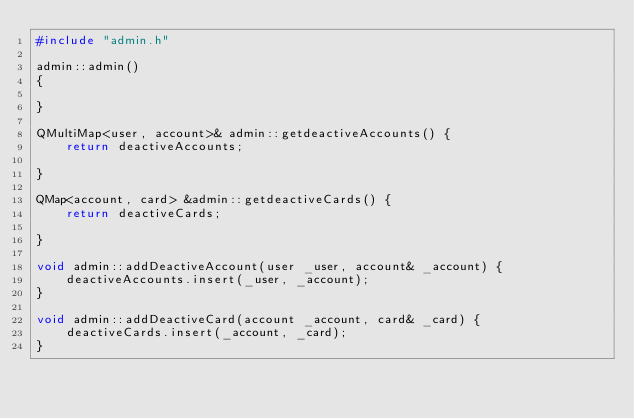Convert code to text. <code><loc_0><loc_0><loc_500><loc_500><_C++_>#include "admin.h"

admin::admin()
{

}

QMultiMap<user, account>& admin::getdeactiveAccounts() {
    return deactiveAccounts;

}

QMap<account, card> &admin::getdeactiveCards() {
    return deactiveCards;

}

void admin::addDeactiveAccount(user _user, account& _account) {
    deactiveAccounts.insert(_user, _account);
}

void admin::addDeactiveCard(account _account, card& _card) {
    deactiveCards.insert(_account, _card);
}
</code> 